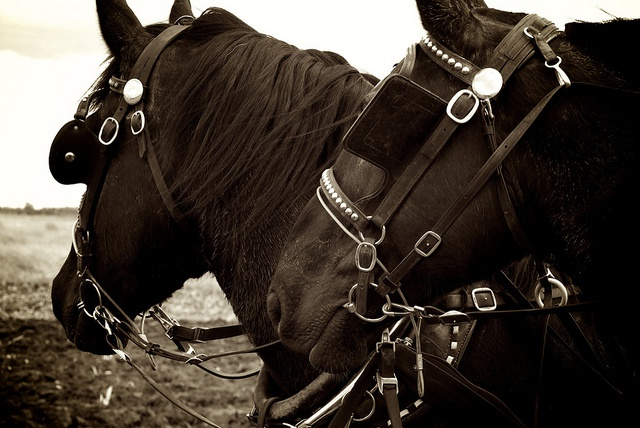Describe the objects in this image and their specific colors. I can see horse in ivory, black, maroon, and gray tones and horse in ivory, black, maroon, and gray tones in this image. 